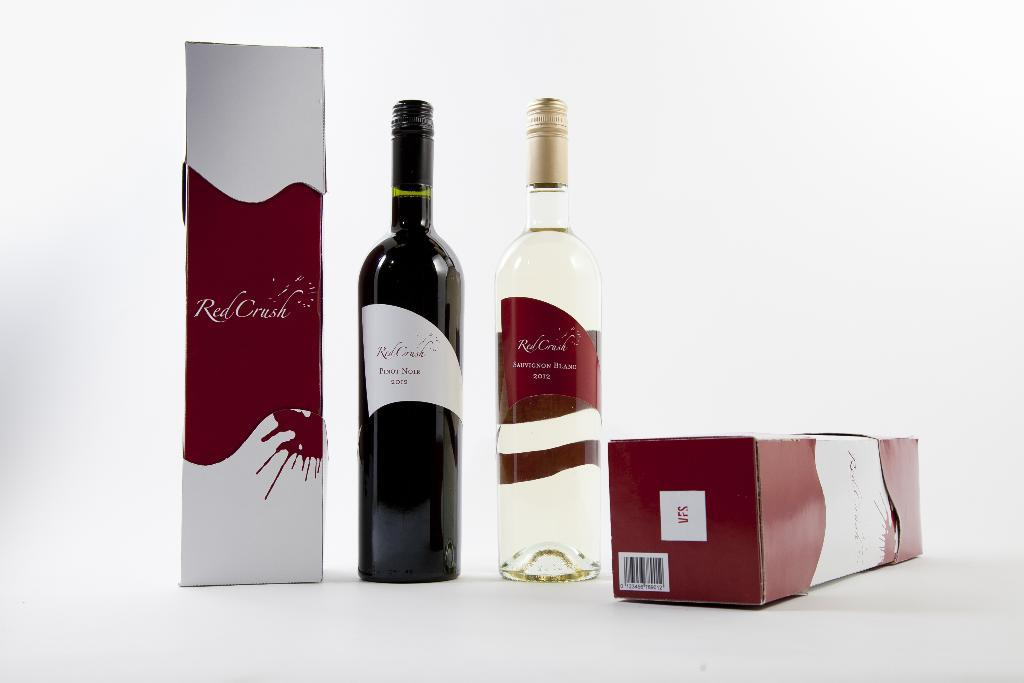Provide a one-sentence caption for the provided image. Bottle of wine next to a box that says Red Creek. 